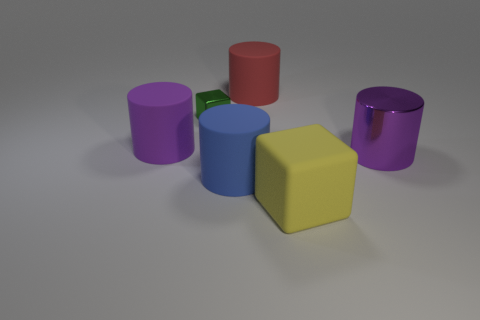There is a big cylinder that is on the right side of the red rubber thing; is its color the same as the large cylinder to the left of the large blue rubber cylinder?
Give a very brief answer. Yes. Are there an equal number of red objects on the left side of the big blue rubber thing and small brown shiny balls?
Provide a short and direct response. Yes. What number of large cylinders are on the right side of the large blue cylinder?
Provide a succinct answer. 2. How big is the blue matte object?
Your response must be concise. Large. What color is the block that is the same material as the big blue thing?
Your answer should be compact. Yellow. What number of yellow metallic cylinders have the same size as the yellow matte thing?
Ensure brevity in your answer.  0. Is the purple cylinder on the left side of the yellow rubber object made of the same material as the small green block?
Provide a short and direct response. No. Are there fewer red cylinders that are in front of the small shiny cube than purple shiny cylinders?
Provide a short and direct response. Yes. There is a purple thing to the right of the tiny object; what shape is it?
Make the answer very short. Cylinder. What is the shape of the yellow rubber thing that is the same size as the red matte cylinder?
Give a very brief answer. Cube. 